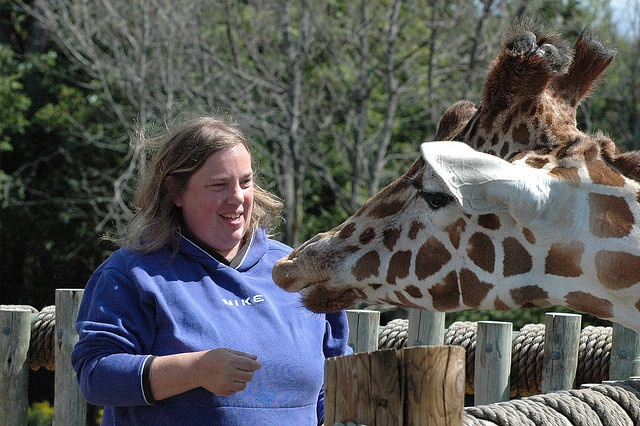Describe the objects in this image and their specific colors. I can see giraffe in darkgreen, gray, black, and maroon tones and people in darkgreen, black, gray, navy, and lightblue tones in this image. 